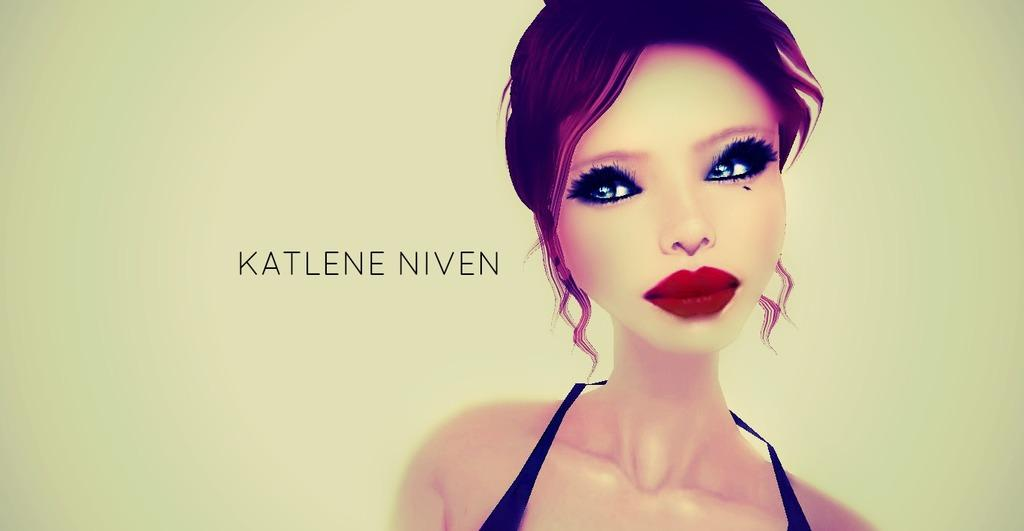What type of image is being described? The image is animated. Who or what is depicted in the animated image? There is a depiction of a woman in the image. Are there any words or letters in the image? Yes, there is text in the image. What type of polish is being applied to the woman's nails in the image? There is no depiction of nail polish or any nail-related activity in the image. Can you see a nest in the background of the image? There is no nest present in the image. 